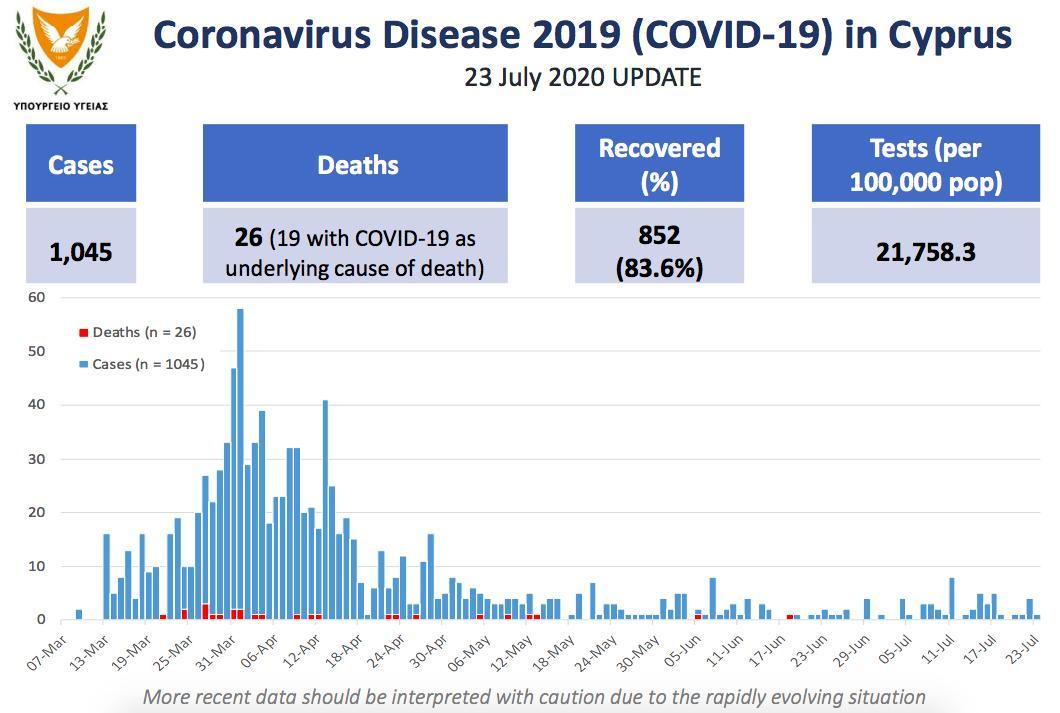How many deaths were registered on June 5th in Cyprus?
Answer the question with a short phrase. 1 How may cases were reported on 19th June? 1 What is difference between number of cases and recovered cases in Cyprus? 193 What was number of COVID cases registered on 13 April? 41 Which week was the first COVID-19 case reported in Cyprus, June 29-Jul 5, 13 Mar-19 Mar, or 7 Mar-Mar ? 7 Mar-13 Mar How many days have reported only deaths and no new cases? 3 Which day had that highest spike in COVID -19 cases in Cyprus, 13 Mar, 14 Mar, or 15 Mar? 14 Mar Which day had the highest number of deaths recorded? 27 Mar 